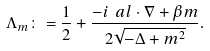Convert formula to latex. <formula><loc_0><loc_0><loc_500><loc_500>\Lambda _ { m } \colon = \frac { 1 } { 2 } + \frac { - i \ a l \cdot \nabla + \beta m } { 2 \sqrt { - \Delta + m ^ { 2 } } } .</formula> 